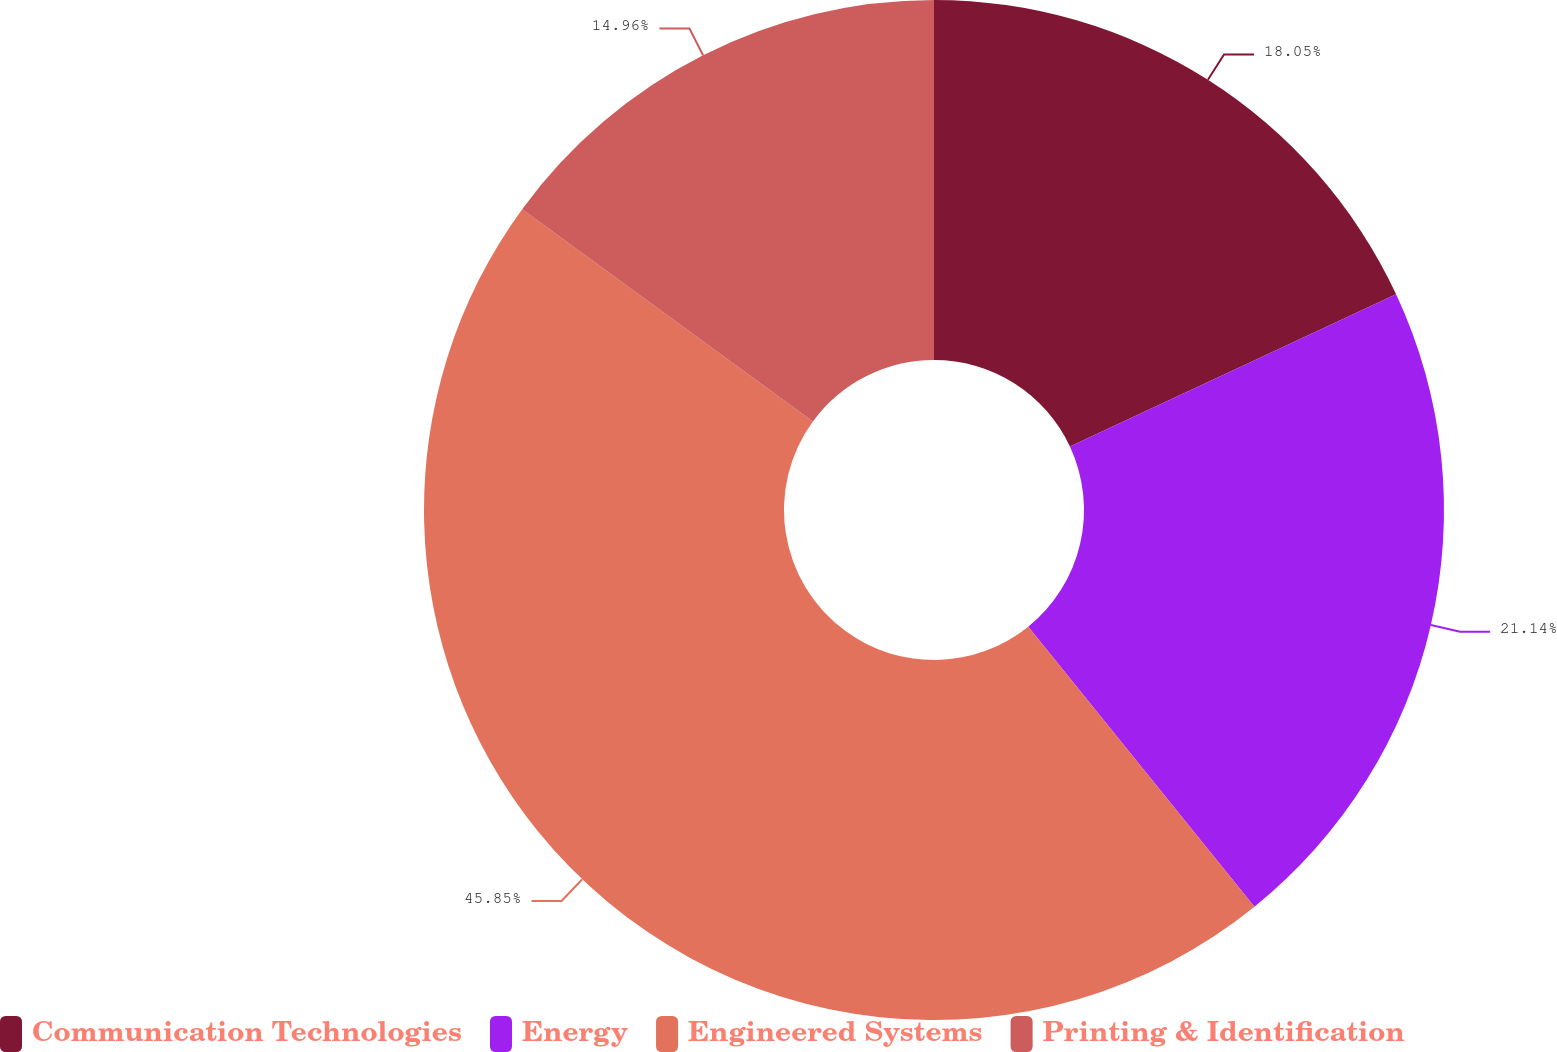<chart> <loc_0><loc_0><loc_500><loc_500><pie_chart><fcel>Communication Technologies<fcel>Energy<fcel>Engineered Systems<fcel>Printing & Identification<nl><fcel>18.05%<fcel>21.14%<fcel>45.86%<fcel>14.96%<nl></chart> 